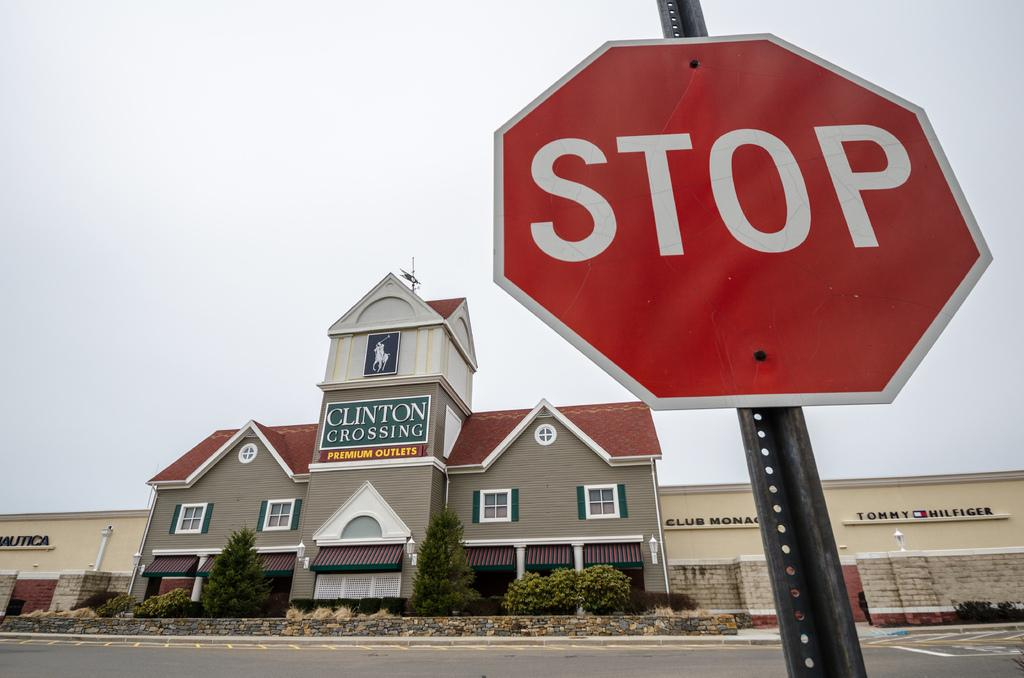<image>
Give a short and clear explanation of the subsequent image. Clinton crossing premium outlet building with a stop sign in front 